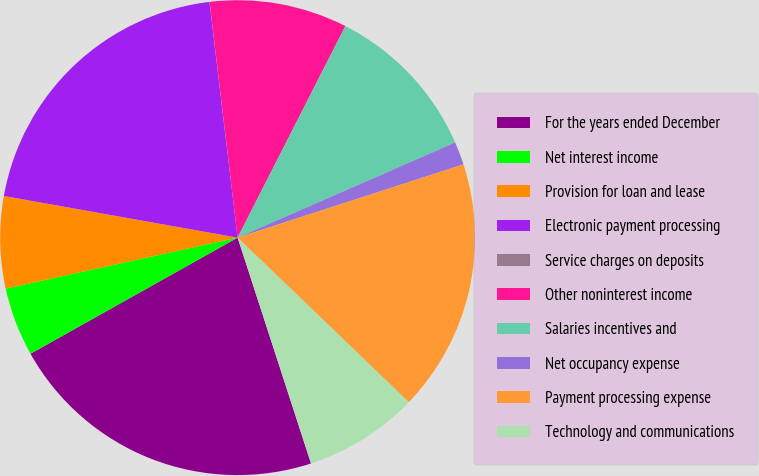Convert chart. <chart><loc_0><loc_0><loc_500><loc_500><pie_chart><fcel>For the years ended December<fcel>Net interest income<fcel>Provision for loan and lease<fcel>Electronic payment processing<fcel>Service charges on deposits<fcel>Other noninterest income<fcel>Salaries incentives and<fcel>Net occupancy expense<fcel>Payment processing expense<fcel>Technology and communications<nl><fcel>21.87%<fcel>4.69%<fcel>6.25%<fcel>20.3%<fcel>0.01%<fcel>9.38%<fcel>10.94%<fcel>1.57%<fcel>17.18%<fcel>7.81%<nl></chart> 